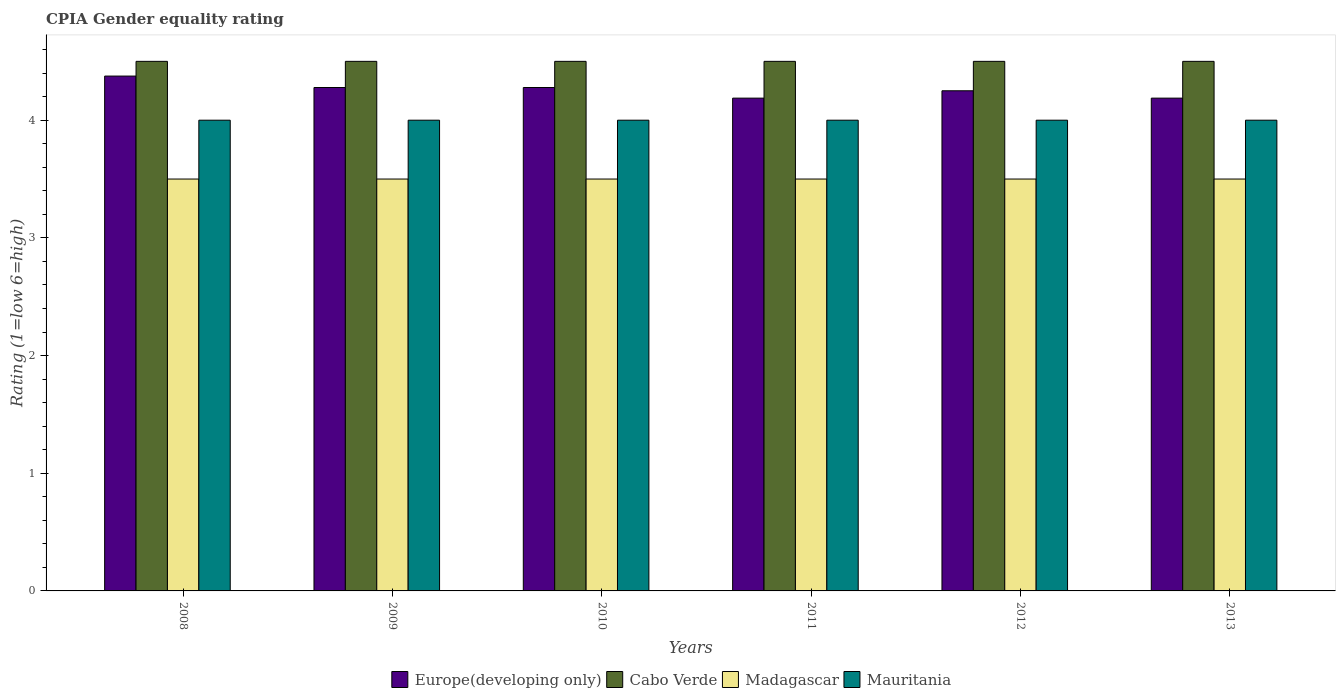How many groups of bars are there?
Provide a succinct answer. 6. How many bars are there on the 6th tick from the left?
Make the answer very short. 4. What is the label of the 5th group of bars from the left?
Your response must be concise. 2012. Across all years, what is the maximum CPIA rating in Mauritania?
Offer a terse response. 4. Across all years, what is the minimum CPIA rating in Madagascar?
Offer a terse response. 3.5. In which year was the CPIA rating in Europe(developing only) minimum?
Make the answer very short. 2011. In the year 2009, what is the difference between the CPIA rating in Europe(developing only) and CPIA rating in Cabo Verde?
Your answer should be compact. -0.22. In how many years, is the CPIA rating in Madagascar greater than 0.4?
Make the answer very short. 6. Is the CPIA rating in Cabo Verde in 2008 less than that in 2011?
Offer a terse response. No. Is the difference between the CPIA rating in Europe(developing only) in 2008 and 2013 greater than the difference between the CPIA rating in Cabo Verde in 2008 and 2013?
Give a very brief answer. Yes. What is the difference between the highest and the second highest CPIA rating in Europe(developing only)?
Keep it short and to the point. 0.1. What is the difference between the highest and the lowest CPIA rating in Cabo Verde?
Your answer should be very brief. 0. Is it the case that in every year, the sum of the CPIA rating in Europe(developing only) and CPIA rating in Mauritania is greater than the sum of CPIA rating in Cabo Verde and CPIA rating in Madagascar?
Give a very brief answer. No. What does the 1st bar from the left in 2012 represents?
Your answer should be very brief. Europe(developing only). What does the 1st bar from the right in 2013 represents?
Ensure brevity in your answer.  Mauritania. How many bars are there?
Your answer should be very brief. 24. Are all the bars in the graph horizontal?
Offer a very short reply. No. How many years are there in the graph?
Make the answer very short. 6. Are the values on the major ticks of Y-axis written in scientific E-notation?
Offer a very short reply. No. Does the graph contain any zero values?
Provide a succinct answer. No. Does the graph contain grids?
Make the answer very short. No. How are the legend labels stacked?
Offer a terse response. Horizontal. What is the title of the graph?
Offer a terse response. CPIA Gender equality rating. What is the label or title of the Y-axis?
Your response must be concise. Rating (1=low 6=high). What is the Rating (1=low 6=high) of Europe(developing only) in 2008?
Ensure brevity in your answer.  4.38. What is the Rating (1=low 6=high) in Cabo Verde in 2008?
Offer a very short reply. 4.5. What is the Rating (1=low 6=high) in Mauritania in 2008?
Give a very brief answer. 4. What is the Rating (1=low 6=high) of Europe(developing only) in 2009?
Offer a very short reply. 4.28. What is the Rating (1=low 6=high) in Europe(developing only) in 2010?
Your response must be concise. 4.28. What is the Rating (1=low 6=high) in Madagascar in 2010?
Your response must be concise. 3.5. What is the Rating (1=low 6=high) in Mauritania in 2010?
Provide a succinct answer. 4. What is the Rating (1=low 6=high) in Europe(developing only) in 2011?
Your answer should be compact. 4.19. What is the Rating (1=low 6=high) of Cabo Verde in 2011?
Provide a short and direct response. 4.5. What is the Rating (1=low 6=high) in Madagascar in 2011?
Offer a very short reply. 3.5. What is the Rating (1=low 6=high) in Europe(developing only) in 2012?
Your response must be concise. 4.25. What is the Rating (1=low 6=high) of Cabo Verde in 2012?
Offer a terse response. 4.5. What is the Rating (1=low 6=high) in Europe(developing only) in 2013?
Your response must be concise. 4.19. What is the Rating (1=low 6=high) in Cabo Verde in 2013?
Your response must be concise. 4.5. What is the Rating (1=low 6=high) in Madagascar in 2013?
Keep it short and to the point. 3.5. Across all years, what is the maximum Rating (1=low 6=high) of Europe(developing only)?
Your answer should be compact. 4.38. Across all years, what is the maximum Rating (1=low 6=high) in Cabo Verde?
Your response must be concise. 4.5. Across all years, what is the maximum Rating (1=low 6=high) in Mauritania?
Give a very brief answer. 4. Across all years, what is the minimum Rating (1=low 6=high) in Europe(developing only)?
Give a very brief answer. 4.19. Across all years, what is the minimum Rating (1=low 6=high) of Madagascar?
Your response must be concise. 3.5. Across all years, what is the minimum Rating (1=low 6=high) of Mauritania?
Offer a very short reply. 4. What is the total Rating (1=low 6=high) in Europe(developing only) in the graph?
Ensure brevity in your answer.  25.56. What is the total Rating (1=low 6=high) in Madagascar in the graph?
Offer a very short reply. 21. What is the total Rating (1=low 6=high) of Mauritania in the graph?
Your answer should be very brief. 24. What is the difference between the Rating (1=low 6=high) of Europe(developing only) in 2008 and that in 2009?
Provide a short and direct response. 0.1. What is the difference between the Rating (1=low 6=high) of Madagascar in 2008 and that in 2009?
Keep it short and to the point. 0. What is the difference between the Rating (1=low 6=high) of Europe(developing only) in 2008 and that in 2010?
Your response must be concise. 0.1. What is the difference between the Rating (1=low 6=high) of Cabo Verde in 2008 and that in 2010?
Keep it short and to the point. 0. What is the difference between the Rating (1=low 6=high) in Europe(developing only) in 2008 and that in 2011?
Provide a succinct answer. 0.19. What is the difference between the Rating (1=low 6=high) in Cabo Verde in 2008 and that in 2011?
Your answer should be compact. 0. What is the difference between the Rating (1=low 6=high) of Madagascar in 2008 and that in 2011?
Ensure brevity in your answer.  0. What is the difference between the Rating (1=low 6=high) of Cabo Verde in 2008 and that in 2012?
Your answer should be very brief. 0. What is the difference between the Rating (1=low 6=high) in Europe(developing only) in 2008 and that in 2013?
Keep it short and to the point. 0.19. What is the difference between the Rating (1=low 6=high) of Cabo Verde in 2008 and that in 2013?
Keep it short and to the point. 0. What is the difference between the Rating (1=low 6=high) of Mauritania in 2008 and that in 2013?
Give a very brief answer. 0. What is the difference between the Rating (1=low 6=high) of Madagascar in 2009 and that in 2010?
Provide a succinct answer. 0. What is the difference between the Rating (1=low 6=high) in Europe(developing only) in 2009 and that in 2011?
Provide a succinct answer. 0.09. What is the difference between the Rating (1=low 6=high) in Mauritania in 2009 and that in 2011?
Ensure brevity in your answer.  0. What is the difference between the Rating (1=low 6=high) in Europe(developing only) in 2009 and that in 2012?
Provide a succinct answer. 0.03. What is the difference between the Rating (1=low 6=high) in Cabo Verde in 2009 and that in 2012?
Ensure brevity in your answer.  0. What is the difference between the Rating (1=low 6=high) of Europe(developing only) in 2009 and that in 2013?
Offer a terse response. 0.09. What is the difference between the Rating (1=low 6=high) of Mauritania in 2009 and that in 2013?
Your answer should be compact. 0. What is the difference between the Rating (1=low 6=high) of Europe(developing only) in 2010 and that in 2011?
Provide a short and direct response. 0.09. What is the difference between the Rating (1=low 6=high) of Cabo Verde in 2010 and that in 2011?
Make the answer very short. 0. What is the difference between the Rating (1=low 6=high) of Madagascar in 2010 and that in 2011?
Your answer should be very brief. 0. What is the difference between the Rating (1=low 6=high) in Mauritania in 2010 and that in 2011?
Your response must be concise. 0. What is the difference between the Rating (1=low 6=high) in Europe(developing only) in 2010 and that in 2012?
Ensure brevity in your answer.  0.03. What is the difference between the Rating (1=low 6=high) in Madagascar in 2010 and that in 2012?
Provide a succinct answer. 0. What is the difference between the Rating (1=low 6=high) in Europe(developing only) in 2010 and that in 2013?
Make the answer very short. 0.09. What is the difference between the Rating (1=low 6=high) in Cabo Verde in 2010 and that in 2013?
Make the answer very short. 0. What is the difference between the Rating (1=low 6=high) of Madagascar in 2010 and that in 2013?
Ensure brevity in your answer.  0. What is the difference between the Rating (1=low 6=high) in Mauritania in 2010 and that in 2013?
Keep it short and to the point. 0. What is the difference between the Rating (1=low 6=high) of Europe(developing only) in 2011 and that in 2012?
Provide a short and direct response. -0.06. What is the difference between the Rating (1=low 6=high) in Cabo Verde in 2011 and that in 2012?
Offer a very short reply. 0. What is the difference between the Rating (1=low 6=high) in Madagascar in 2011 and that in 2012?
Offer a very short reply. 0. What is the difference between the Rating (1=low 6=high) of Mauritania in 2011 and that in 2012?
Make the answer very short. 0. What is the difference between the Rating (1=low 6=high) of Cabo Verde in 2011 and that in 2013?
Your answer should be compact. 0. What is the difference between the Rating (1=low 6=high) of Madagascar in 2011 and that in 2013?
Make the answer very short. 0. What is the difference between the Rating (1=low 6=high) in Mauritania in 2011 and that in 2013?
Give a very brief answer. 0. What is the difference between the Rating (1=low 6=high) in Europe(developing only) in 2012 and that in 2013?
Provide a succinct answer. 0.06. What is the difference between the Rating (1=low 6=high) of Cabo Verde in 2012 and that in 2013?
Make the answer very short. 0. What is the difference between the Rating (1=low 6=high) of Europe(developing only) in 2008 and the Rating (1=low 6=high) of Cabo Verde in 2009?
Your answer should be compact. -0.12. What is the difference between the Rating (1=low 6=high) of Europe(developing only) in 2008 and the Rating (1=low 6=high) of Madagascar in 2009?
Offer a terse response. 0.88. What is the difference between the Rating (1=low 6=high) in Cabo Verde in 2008 and the Rating (1=low 6=high) in Madagascar in 2009?
Provide a short and direct response. 1. What is the difference between the Rating (1=low 6=high) of Cabo Verde in 2008 and the Rating (1=low 6=high) of Mauritania in 2009?
Your answer should be compact. 0.5. What is the difference between the Rating (1=low 6=high) in Madagascar in 2008 and the Rating (1=low 6=high) in Mauritania in 2009?
Keep it short and to the point. -0.5. What is the difference between the Rating (1=low 6=high) in Europe(developing only) in 2008 and the Rating (1=low 6=high) in Cabo Verde in 2010?
Give a very brief answer. -0.12. What is the difference between the Rating (1=low 6=high) of Europe(developing only) in 2008 and the Rating (1=low 6=high) of Madagascar in 2010?
Provide a succinct answer. 0.88. What is the difference between the Rating (1=low 6=high) of Cabo Verde in 2008 and the Rating (1=low 6=high) of Madagascar in 2010?
Give a very brief answer. 1. What is the difference between the Rating (1=low 6=high) of Cabo Verde in 2008 and the Rating (1=low 6=high) of Mauritania in 2010?
Provide a short and direct response. 0.5. What is the difference between the Rating (1=low 6=high) in Madagascar in 2008 and the Rating (1=low 6=high) in Mauritania in 2010?
Make the answer very short. -0.5. What is the difference between the Rating (1=low 6=high) in Europe(developing only) in 2008 and the Rating (1=low 6=high) in Cabo Verde in 2011?
Offer a terse response. -0.12. What is the difference between the Rating (1=low 6=high) in Europe(developing only) in 2008 and the Rating (1=low 6=high) in Madagascar in 2011?
Offer a very short reply. 0.88. What is the difference between the Rating (1=low 6=high) in Europe(developing only) in 2008 and the Rating (1=low 6=high) in Mauritania in 2011?
Provide a short and direct response. 0.38. What is the difference between the Rating (1=low 6=high) of Cabo Verde in 2008 and the Rating (1=low 6=high) of Madagascar in 2011?
Your answer should be compact. 1. What is the difference between the Rating (1=low 6=high) in Europe(developing only) in 2008 and the Rating (1=low 6=high) in Cabo Verde in 2012?
Your answer should be compact. -0.12. What is the difference between the Rating (1=low 6=high) of Europe(developing only) in 2008 and the Rating (1=low 6=high) of Cabo Verde in 2013?
Keep it short and to the point. -0.12. What is the difference between the Rating (1=low 6=high) of Europe(developing only) in 2008 and the Rating (1=low 6=high) of Madagascar in 2013?
Give a very brief answer. 0.88. What is the difference between the Rating (1=low 6=high) of Europe(developing only) in 2008 and the Rating (1=low 6=high) of Mauritania in 2013?
Your answer should be compact. 0.38. What is the difference between the Rating (1=low 6=high) in Madagascar in 2008 and the Rating (1=low 6=high) in Mauritania in 2013?
Your answer should be compact. -0.5. What is the difference between the Rating (1=low 6=high) in Europe(developing only) in 2009 and the Rating (1=low 6=high) in Cabo Verde in 2010?
Give a very brief answer. -0.22. What is the difference between the Rating (1=low 6=high) of Europe(developing only) in 2009 and the Rating (1=low 6=high) of Mauritania in 2010?
Provide a short and direct response. 0.28. What is the difference between the Rating (1=low 6=high) of Cabo Verde in 2009 and the Rating (1=low 6=high) of Madagascar in 2010?
Offer a very short reply. 1. What is the difference between the Rating (1=low 6=high) in Cabo Verde in 2009 and the Rating (1=low 6=high) in Mauritania in 2010?
Provide a short and direct response. 0.5. What is the difference between the Rating (1=low 6=high) of Europe(developing only) in 2009 and the Rating (1=low 6=high) of Cabo Verde in 2011?
Provide a short and direct response. -0.22. What is the difference between the Rating (1=low 6=high) of Europe(developing only) in 2009 and the Rating (1=low 6=high) of Mauritania in 2011?
Provide a short and direct response. 0.28. What is the difference between the Rating (1=low 6=high) of Cabo Verde in 2009 and the Rating (1=low 6=high) of Madagascar in 2011?
Offer a very short reply. 1. What is the difference between the Rating (1=low 6=high) of Europe(developing only) in 2009 and the Rating (1=low 6=high) of Cabo Verde in 2012?
Your answer should be very brief. -0.22. What is the difference between the Rating (1=low 6=high) of Europe(developing only) in 2009 and the Rating (1=low 6=high) of Madagascar in 2012?
Your response must be concise. 0.78. What is the difference between the Rating (1=low 6=high) in Europe(developing only) in 2009 and the Rating (1=low 6=high) in Mauritania in 2012?
Your answer should be compact. 0.28. What is the difference between the Rating (1=low 6=high) in Cabo Verde in 2009 and the Rating (1=low 6=high) in Madagascar in 2012?
Offer a terse response. 1. What is the difference between the Rating (1=low 6=high) of Cabo Verde in 2009 and the Rating (1=low 6=high) of Mauritania in 2012?
Keep it short and to the point. 0.5. What is the difference between the Rating (1=low 6=high) in Madagascar in 2009 and the Rating (1=low 6=high) in Mauritania in 2012?
Keep it short and to the point. -0.5. What is the difference between the Rating (1=low 6=high) of Europe(developing only) in 2009 and the Rating (1=low 6=high) of Cabo Verde in 2013?
Provide a short and direct response. -0.22. What is the difference between the Rating (1=low 6=high) in Europe(developing only) in 2009 and the Rating (1=low 6=high) in Mauritania in 2013?
Your answer should be compact. 0.28. What is the difference between the Rating (1=low 6=high) in Madagascar in 2009 and the Rating (1=low 6=high) in Mauritania in 2013?
Provide a short and direct response. -0.5. What is the difference between the Rating (1=low 6=high) of Europe(developing only) in 2010 and the Rating (1=low 6=high) of Cabo Verde in 2011?
Make the answer very short. -0.22. What is the difference between the Rating (1=low 6=high) in Europe(developing only) in 2010 and the Rating (1=low 6=high) in Madagascar in 2011?
Your answer should be very brief. 0.78. What is the difference between the Rating (1=low 6=high) of Europe(developing only) in 2010 and the Rating (1=low 6=high) of Mauritania in 2011?
Provide a short and direct response. 0.28. What is the difference between the Rating (1=low 6=high) of Cabo Verde in 2010 and the Rating (1=low 6=high) of Mauritania in 2011?
Your answer should be very brief. 0.5. What is the difference between the Rating (1=low 6=high) in Europe(developing only) in 2010 and the Rating (1=low 6=high) in Cabo Verde in 2012?
Provide a short and direct response. -0.22. What is the difference between the Rating (1=low 6=high) of Europe(developing only) in 2010 and the Rating (1=low 6=high) of Madagascar in 2012?
Ensure brevity in your answer.  0.78. What is the difference between the Rating (1=low 6=high) of Europe(developing only) in 2010 and the Rating (1=low 6=high) of Mauritania in 2012?
Provide a succinct answer. 0.28. What is the difference between the Rating (1=low 6=high) of Cabo Verde in 2010 and the Rating (1=low 6=high) of Madagascar in 2012?
Ensure brevity in your answer.  1. What is the difference between the Rating (1=low 6=high) in Europe(developing only) in 2010 and the Rating (1=low 6=high) in Cabo Verde in 2013?
Provide a succinct answer. -0.22. What is the difference between the Rating (1=low 6=high) of Europe(developing only) in 2010 and the Rating (1=low 6=high) of Madagascar in 2013?
Your answer should be compact. 0.78. What is the difference between the Rating (1=low 6=high) of Europe(developing only) in 2010 and the Rating (1=low 6=high) of Mauritania in 2013?
Provide a short and direct response. 0.28. What is the difference between the Rating (1=low 6=high) in Madagascar in 2010 and the Rating (1=low 6=high) in Mauritania in 2013?
Your response must be concise. -0.5. What is the difference between the Rating (1=low 6=high) of Europe(developing only) in 2011 and the Rating (1=low 6=high) of Cabo Verde in 2012?
Your response must be concise. -0.31. What is the difference between the Rating (1=low 6=high) in Europe(developing only) in 2011 and the Rating (1=low 6=high) in Madagascar in 2012?
Your answer should be very brief. 0.69. What is the difference between the Rating (1=low 6=high) of Europe(developing only) in 2011 and the Rating (1=low 6=high) of Mauritania in 2012?
Provide a succinct answer. 0.19. What is the difference between the Rating (1=low 6=high) of Cabo Verde in 2011 and the Rating (1=low 6=high) of Mauritania in 2012?
Provide a short and direct response. 0.5. What is the difference between the Rating (1=low 6=high) of Europe(developing only) in 2011 and the Rating (1=low 6=high) of Cabo Verde in 2013?
Offer a terse response. -0.31. What is the difference between the Rating (1=low 6=high) in Europe(developing only) in 2011 and the Rating (1=low 6=high) in Madagascar in 2013?
Offer a terse response. 0.69. What is the difference between the Rating (1=low 6=high) of Europe(developing only) in 2011 and the Rating (1=low 6=high) of Mauritania in 2013?
Ensure brevity in your answer.  0.19. What is the difference between the Rating (1=low 6=high) of Cabo Verde in 2011 and the Rating (1=low 6=high) of Madagascar in 2013?
Your response must be concise. 1. What is the difference between the Rating (1=low 6=high) in Cabo Verde in 2011 and the Rating (1=low 6=high) in Mauritania in 2013?
Your response must be concise. 0.5. What is the difference between the Rating (1=low 6=high) in Europe(developing only) in 2012 and the Rating (1=low 6=high) in Mauritania in 2013?
Your answer should be compact. 0.25. What is the difference between the Rating (1=low 6=high) in Cabo Verde in 2012 and the Rating (1=low 6=high) in Madagascar in 2013?
Offer a terse response. 1. What is the difference between the Rating (1=low 6=high) of Cabo Verde in 2012 and the Rating (1=low 6=high) of Mauritania in 2013?
Provide a succinct answer. 0.5. What is the difference between the Rating (1=low 6=high) of Madagascar in 2012 and the Rating (1=low 6=high) of Mauritania in 2013?
Provide a succinct answer. -0.5. What is the average Rating (1=low 6=high) of Europe(developing only) per year?
Give a very brief answer. 4.26. What is the average Rating (1=low 6=high) in Cabo Verde per year?
Make the answer very short. 4.5. What is the average Rating (1=low 6=high) in Madagascar per year?
Make the answer very short. 3.5. What is the average Rating (1=low 6=high) in Mauritania per year?
Your answer should be compact. 4. In the year 2008, what is the difference between the Rating (1=low 6=high) in Europe(developing only) and Rating (1=low 6=high) in Cabo Verde?
Your answer should be very brief. -0.12. In the year 2008, what is the difference between the Rating (1=low 6=high) in Europe(developing only) and Rating (1=low 6=high) in Mauritania?
Offer a very short reply. 0.38. In the year 2008, what is the difference between the Rating (1=low 6=high) in Cabo Verde and Rating (1=low 6=high) in Mauritania?
Your answer should be compact. 0.5. In the year 2008, what is the difference between the Rating (1=low 6=high) of Madagascar and Rating (1=low 6=high) of Mauritania?
Your answer should be compact. -0.5. In the year 2009, what is the difference between the Rating (1=low 6=high) in Europe(developing only) and Rating (1=low 6=high) in Cabo Verde?
Give a very brief answer. -0.22. In the year 2009, what is the difference between the Rating (1=low 6=high) of Europe(developing only) and Rating (1=low 6=high) of Mauritania?
Keep it short and to the point. 0.28. In the year 2009, what is the difference between the Rating (1=low 6=high) of Madagascar and Rating (1=low 6=high) of Mauritania?
Ensure brevity in your answer.  -0.5. In the year 2010, what is the difference between the Rating (1=low 6=high) of Europe(developing only) and Rating (1=low 6=high) of Cabo Verde?
Offer a terse response. -0.22. In the year 2010, what is the difference between the Rating (1=low 6=high) of Europe(developing only) and Rating (1=low 6=high) of Madagascar?
Keep it short and to the point. 0.78. In the year 2010, what is the difference between the Rating (1=low 6=high) in Europe(developing only) and Rating (1=low 6=high) in Mauritania?
Provide a short and direct response. 0.28. In the year 2010, what is the difference between the Rating (1=low 6=high) in Cabo Verde and Rating (1=low 6=high) in Madagascar?
Give a very brief answer. 1. In the year 2011, what is the difference between the Rating (1=low 6=high) in Europe(developing only) and Rating (1=low 6=high) in Cabo Verde?
Your answer should be compact. -0.31. In the year 2011, what is the difference between the Rating (1=low 6=high) in Europe(developing only) and Rating (1=low 6=high) in Madagascar?
Your answer should be very brief. 0.69. In the year 2011, what is the difference between the Rating (1=low 6=high) in Europe(developing only) and Rating (1=low 6=high) in Mauritania?
Provide a succinct answer. 0.19. In the year 2011, what is the difference between the Rating (1=low 6=high) of Cabo Verde and Rating (1=low 6=high) of Madagascar?
Keep it short and to the point. 1. In the year 2011, what is the difference between the Rating (1=low 6=high) of Cabo Verde and Rating (1=low 6=high) of Mauritania?
Keep it short and to the point. 0.5. In the year 2012, what is the difference between the Rating (1=low 6=high) in Europe(developing only) and Rating (1=low 6=high) in Madagascar?
Your answer should be compact. 0.75. In the year 2012, what is the difference between the Rating (1=low 6=high) of Cabo Verde and Rating (1=low 6=high) of Madagascar?
Ensure brevity in your answer.  1. In the year 2012, what is the difference between the Rating (1=low 6=high) of Cabo Verde and Rating (1=low 6=high) of Mauritania?
Give a very brief answer. 0.5. In the year 2013, what is the difference between the Rating (1=low 6=high) of Europe(developing only) and Rating (1=low 6=high) of Cabo Verde?
Give a very brief answer. -0.31. In the year 2013, what is the difference between the Rating (1=low 6=high) in Europe(developing only) and Rating (1=low 6=high) in Madagascar?
Provide a succinct answer. 0.69. In the year 2013, what is the difference between the Rating (1=low 6=high) in Europe(developing only) and Rating (1=low 6=high) in Mauritania?
Your answer should be very brief. 0.19. In the year 2013, what is the difference between the Rating (1=low 6=high) of Cabo Verde and Rating (1=low 6=high) of Mauritania?
Ensure brevity in your answer.  0.5. What is the ratio of the Rating (1=low 6=high) of Europe(developing only) in 2008 to that in 2009?
Make the answer very short. 1.02. What is the ratio of the Rating (1=low 6=high) in Cabo Verde in 2008 to that in 2009?
Ensure brevity in your answer.  1. What is the ratio of the Rating (1=low 6=high) of Madagascar in 2008 to that in 2009?
Make the answer very short. 1. What is the ratio of the Rating (1=low 6=high) in Mauritania in 2008 to that in 2009?
Your answer should be very brief. 1. What is the ratio of the Rating (1=low 6=high) in Europe(developing only) in 2008 to that in 2010?
Offer a terse response. 1.02. What is the ratio of the Rating (1=low 6=high) of Cabo Verde in 2008 to that in 2010?
Make the answer very short. 1. What is the ratio of the Rating (1=low 6=high) of Europe(developing only) in 2008 to that in 2011?
Keep it short and to the point. 1.04. What is the ratio of the Rating (1=low 6=high) in Madagascar in 2008 to that in 2011?
Offer a very short reply. 1. What is the ratio of the Rating (1=low 6=high) in Europe(developing only) in 2008 to that in 2012?
Keep it short and to the point. 1.03. What is the ratio of the Rating (1=low 6=high) of Madagascar in 2008 to that in 2012?
Your answer should be compact. 1. What is the ratio of the Rating (1=low 6=high) in Mauritania in 2008 to that in 2012?
Keep it short and to the point. 1. What is the ratio of the Rating (1=low 6=high) of Europe(developing only) in 2008 to that in 2013?
Offer a very short reply. 1.04. What is the ratio of the Rating (1=low 6=high) of Madagascar in 2008 to that in 2013?
Provide a short and direct response. 1. What is the ratio of the Rating (1=low 6=high) in Mauritania in 2008 to that in 2013?
Provide a succinct answer. 1. What is the ratio of the Rating (1=low 6=high) in Europe(developing only) in 2009 to that in 2010?
Provide a succinct answer. 1. What is the ratio of the Rating (1=low 6=high) of Cabo Verde in 2009 to that in 2010?
Offer a very short reply. 1. What is the ratio of the Rating (1=low 6=high) in Madagascar in 2009 to that in 2010?
Your answer should be very brief. 1. What is the ratio of the Rating (1=low 6=high) in Europe(developing only) in 2009 to that in 2011?
Your response must be concise. 1.02. What is the ratio of the Rating (1=low 6=high) in Mauritania in 2009 to that in 2011?
Provide a succinct answer. 1. What is the ratio of the Rating (1=low 6=high) in Madagascar in 2009 to that in 2012?
Ensure brevity in your answer.  1. What is the ratio of the Rating (1=low 6=high) in Mauritania in 2009 to that in 2012?
Offer a terse response. 1. What is the ratio of the Rating (1=low 6=high) in Europe(developing only) in 2009 to that in 2013?
Offer a terse response. 1.02. What is the ratio of the Rating (1=low 6=high) in Mauritania in 2009 to that in 2013?
Your answer should be compact. 1. What is the ratio of the Rating (1=low 6=high) of Europe(developing only) in 2010 to that in 2011?
Ensure brevity in your answer.  1.02. What is the ratio of the Rating (1=low 6=high) of Mauritania in 2010 to that in 2011?
Your answer should be compact. 1. What is the ratio of the Rating (1=low 6=high) of Europe(developing only) in 2010 to that in 2012?
Provide a succinct answer. 1.01. What is the ratio of the Rating (1=low 6=high) of Madagascar in 2010 to that in 2012?
Your response must be concise. 1. What is the ratio of the Rating (1=low 6=high) in Europe(developing only) in 2010 to that in 2013?
Offer a terse response. 1.02. What is the ratio of the Rating (1=low 6=high) in Mauritania in 2010 to that in 2013?
Keep it short and to the point. 1. What is the ratio of the Rating (1=low 6=high) in Cabo Verde in 2011 to that in 2012?
Your response must be concise. 1. What is the ratio of the Rating (1=low 6=high) of Mauritania in 2011 to that in 2012?
Make the answer very short. 1. What is the ratio of the Rating (1=low 6=high) in Madagascar in 2011 to that in 2013?
Provide a short and direct response. 1. What is the ratio of the Rating (1=low 6=high) in Europe(developing only) in 2012 to that in 2013?
Make the answer very short. 1.01. What is the ratio of the Rating (1=low 6=high) in Madagascar in 2012 to that in 2013?
Give a very brief answer. 1. What is the ratio of the Rating (1=low 6=high) in Mauritania in 2012 to that in 2013?
Give a very brief answer. 1. What is the difference between the highest and the second highest Rating (1=low 6=high) of Europe(developing only)?
Ensure brevity in your answer.  0.1. What is the difference between the highest and the second highest Rating (1=low 6=high) of Cabo Verde?
Ensure brevity in your answer.  0. What is the difference between the highest and the second highest Rating (1=low 6=high) in Madagascar?
Provide a succinct answer. 0. What is the difference between the highest and the lowest Rating (1=low 6=high) in Europe(developing only)?
Keep it short and to the point. 0.19. 